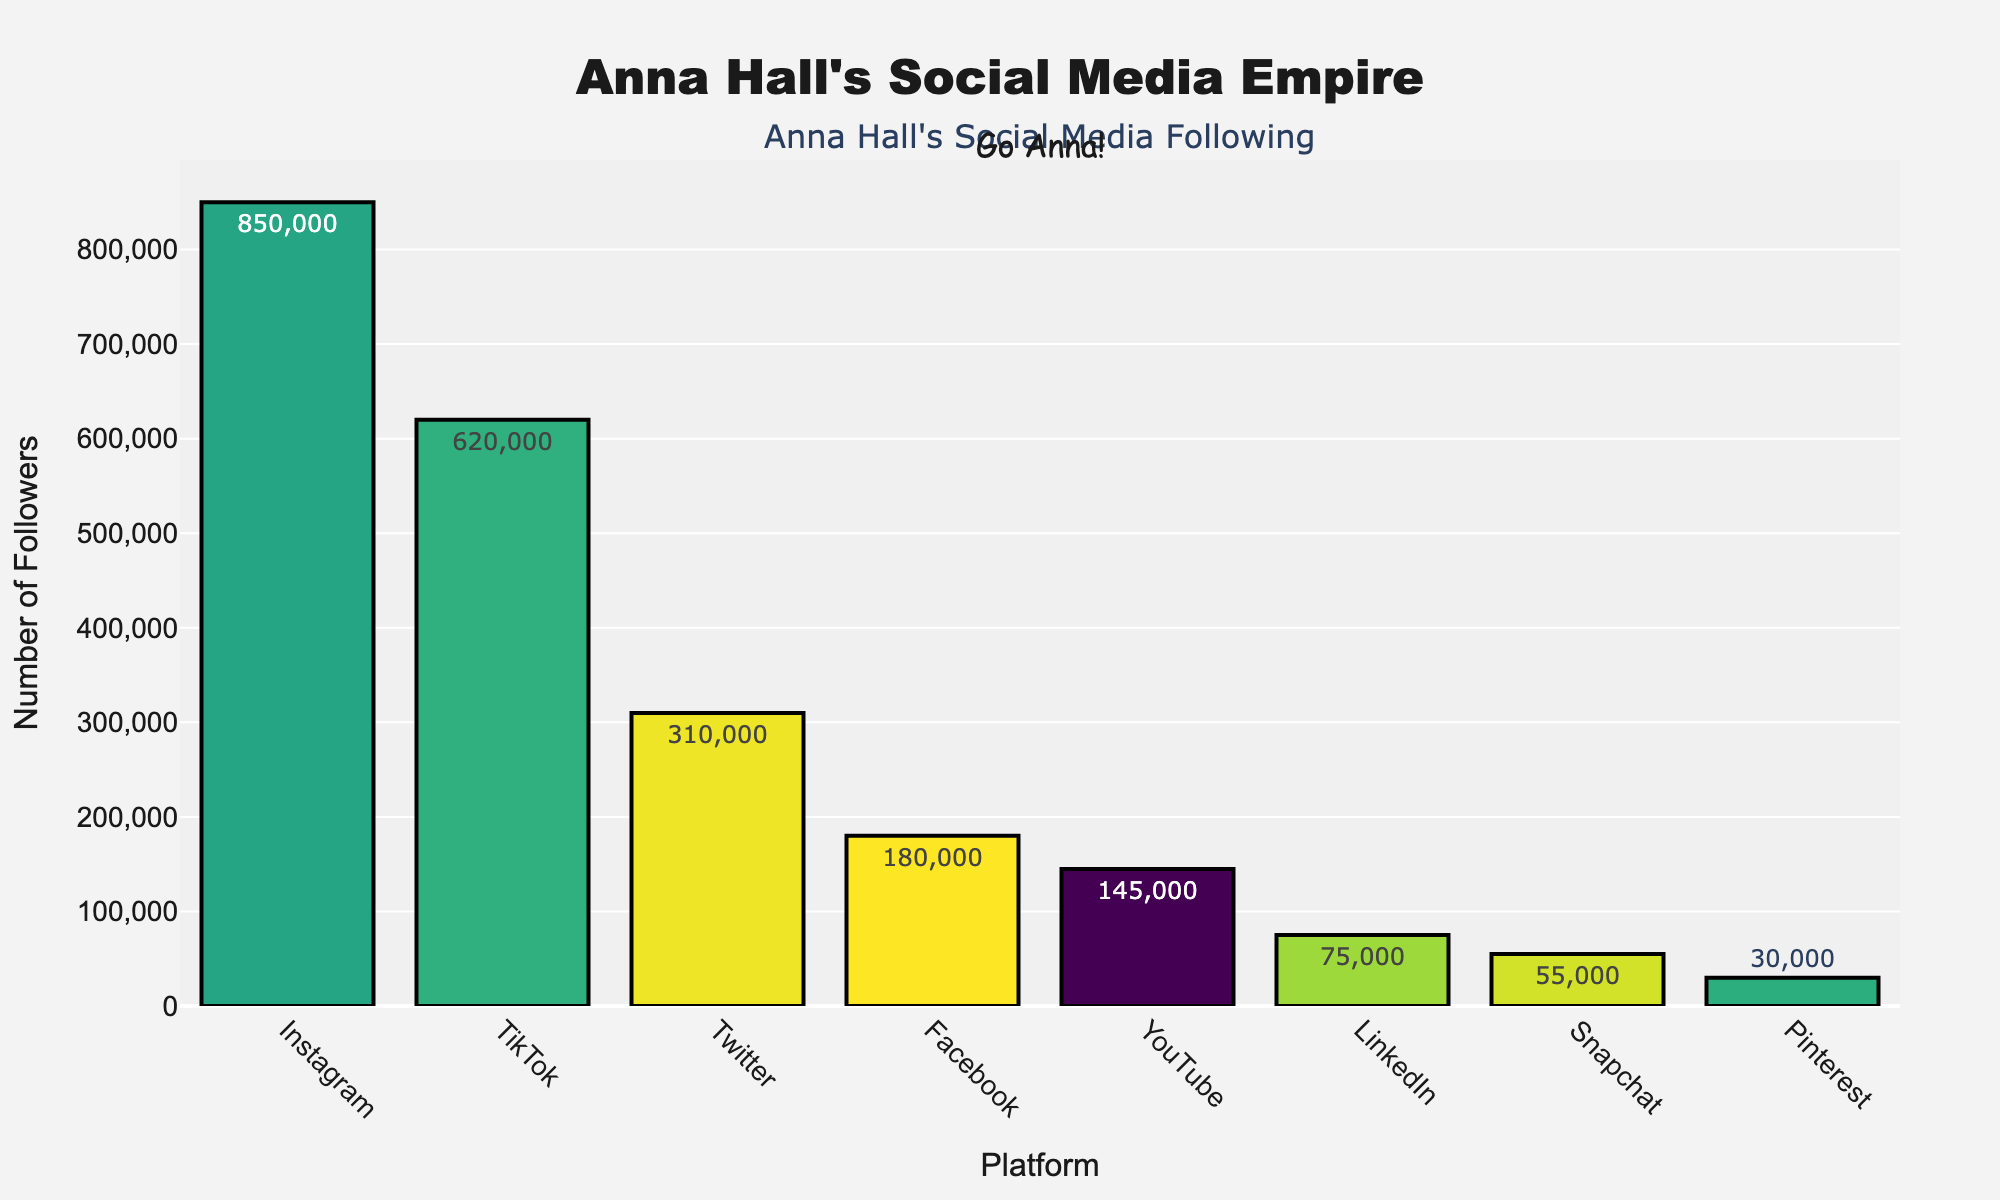what platform has the highest number of followers? The platform with the tallest bar in the chart indicates the highest number of followers. By observing the figure, Instagram has the tallest bar.
Answer: Instagram How many total followers does Anna Hall have across all platforms? Sum up the number of followers across all platforms (850,000 + 620,000 + 310,000 + 180,000 + 145,000 + 75,000 + 55,000 + 30,000). The sum is 2,265,000.
Answer: 2,265,000 How many more followers does Instagram have compared to Facebook? Instagram has 850,000 followers and Facebook has 180,000 followers. Subtract the number of Facebook followers from the number of Instagram followers (850,000 - 180,000). The difference is 670,000.
Answer: 670,000 Which platform has the lowest number of followers? The platform with the shortest bar in the chart indicates the lowest number of followers. By observing the figure, Pinterest has the shortest bar.
Answer: Pinterest What is the average number of followers across all platforms? Sum the number of followers across all platforms (2,265,000) and divide by the number of platforms (8). The average is 2,265,000 / 8.
Answer: 283,125 Which platform has fewer followers: LinkedIn or YouTube? Compare the heights of the bars for LinkedIn and YouTube. YouTube has a taller bar with 145,000 followers compared to LinkedIn's 75,000 followers.
Answer: LinkedIn How does the number of Twitter followers compare to the number of TikTok followers? Compare the heights of the bars for Twitter and TikTok. TikTok has a taller bar with 620,000 followers, while Twitter has a shorter bar with 310,000 followers. TikTok has more followers.
Answer: TikTok has more followers What is the difference in follower count between YouTube and Snapchat? Subtract the number of followers of Snapchat (55,000) from YouTube (145,000). The difference is 145,000 - 55,000.
Answer: 90,000 Which platforms have follower counts above 500,000? Identify the platforms with bars higher than 500,000 on the y-axis. Both Instagram and TikTok meet this criterion.
Answer: Instagram and TikTok 